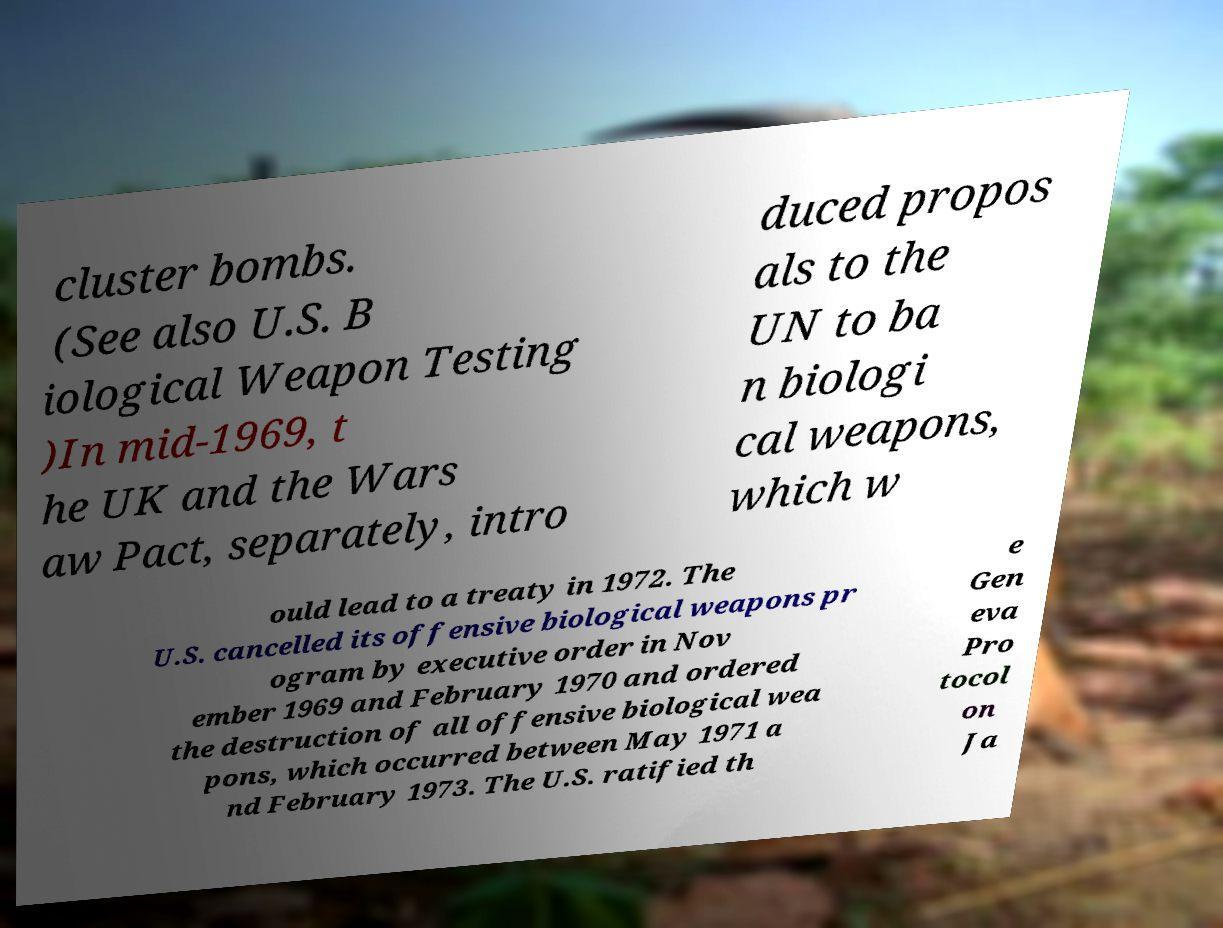I need the written content from this picture converted into text. Can you do that? cluster bombs. (See also U.S. B iological Weapon Testing )In mid-1969, t he UK and the Wars aw Pact, separately, intro duced propos als to the UN to ba n biologi cal weapons, which w ould lead to a treaty in 1972. The U.S. cancelled its offensive biological weapons pr ogram by executive order in Nov ember 1969 and February 1970 and ordered the destruction of all offensive biological wea pons, which occurred between May 1971 a nd February 1973. The U.S. ratified th e Gen eva Pro tocol on Ja 